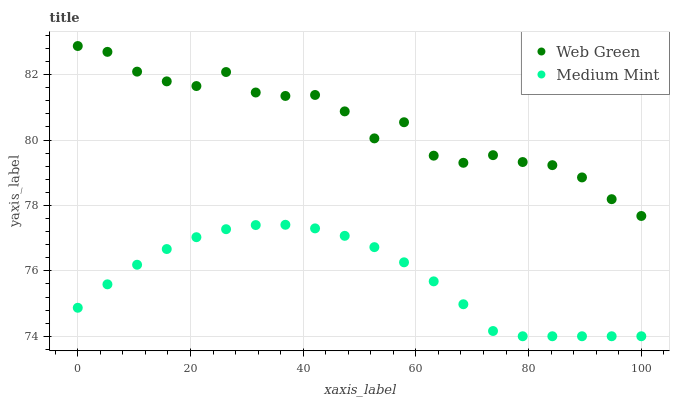Does Medium Mint have the minimum area under the curve?
Answer yes or no. Yes. Does Web Green have the maximum area under the curve?
Answer yes or no. Yes. Does Web Green have the minimum area under the curve?
Answer yes or no. No. Is Medium Mint the smoothest?
Answer yes or no. Yes. Is Web Green the roughest?
Answer yes or no. Yes. Is Web Green the smoothest?
Answer yes or no. No. Does Medium Mint have the lowest value?
Answer yes or no. Yes. Does Web Green have the lowest value?
Answer yes or no. No. Does Web Green have the highest value?
Answer yes or no. Yes. Is Medium Mint less than Web Green?
Answer yes or no. Yes. Is Web Green greater than Medium Mint?
Answer yes or no. Yes. Does Medium Mint intersect Web Green?
Answer yes or no. No. 